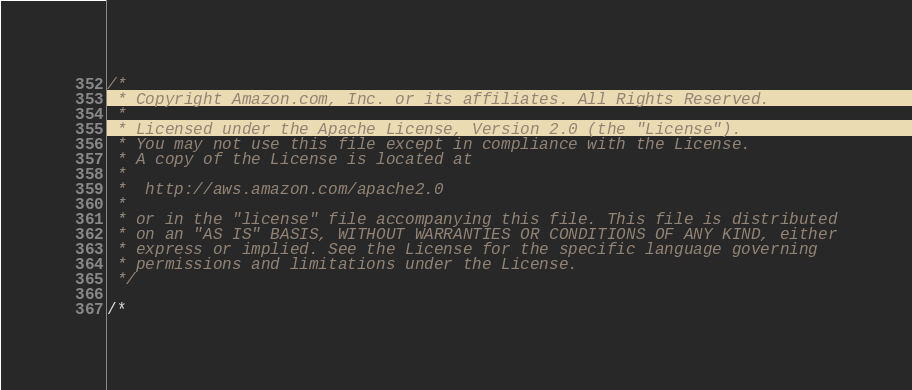Convert code to text. <code><loc_0><loc_0><loc_500><loc_500><_C#_>/*
 * Copyright Amazon.com, Inc. or its affiliates. All Rights Reserved.
 * 
 * Licensed under the Apache License, Version 2.0 (the "License").
 * You may not use this file except in compliance with the License.
 * A copy of the License is located at
 * 
 *  http://aws.amazon.com/apache2.0
 * 
 * or in the "license" file accompanying this file. This file is distributed
 * on an "AS IS" BASIS, WITHOUT WARRANTIES OR CONDITIONS OF ANY KIND, either
 * express or implied. See the License for the specific language governing
 * permissions and limitations under the License.
 */

/*</code> 